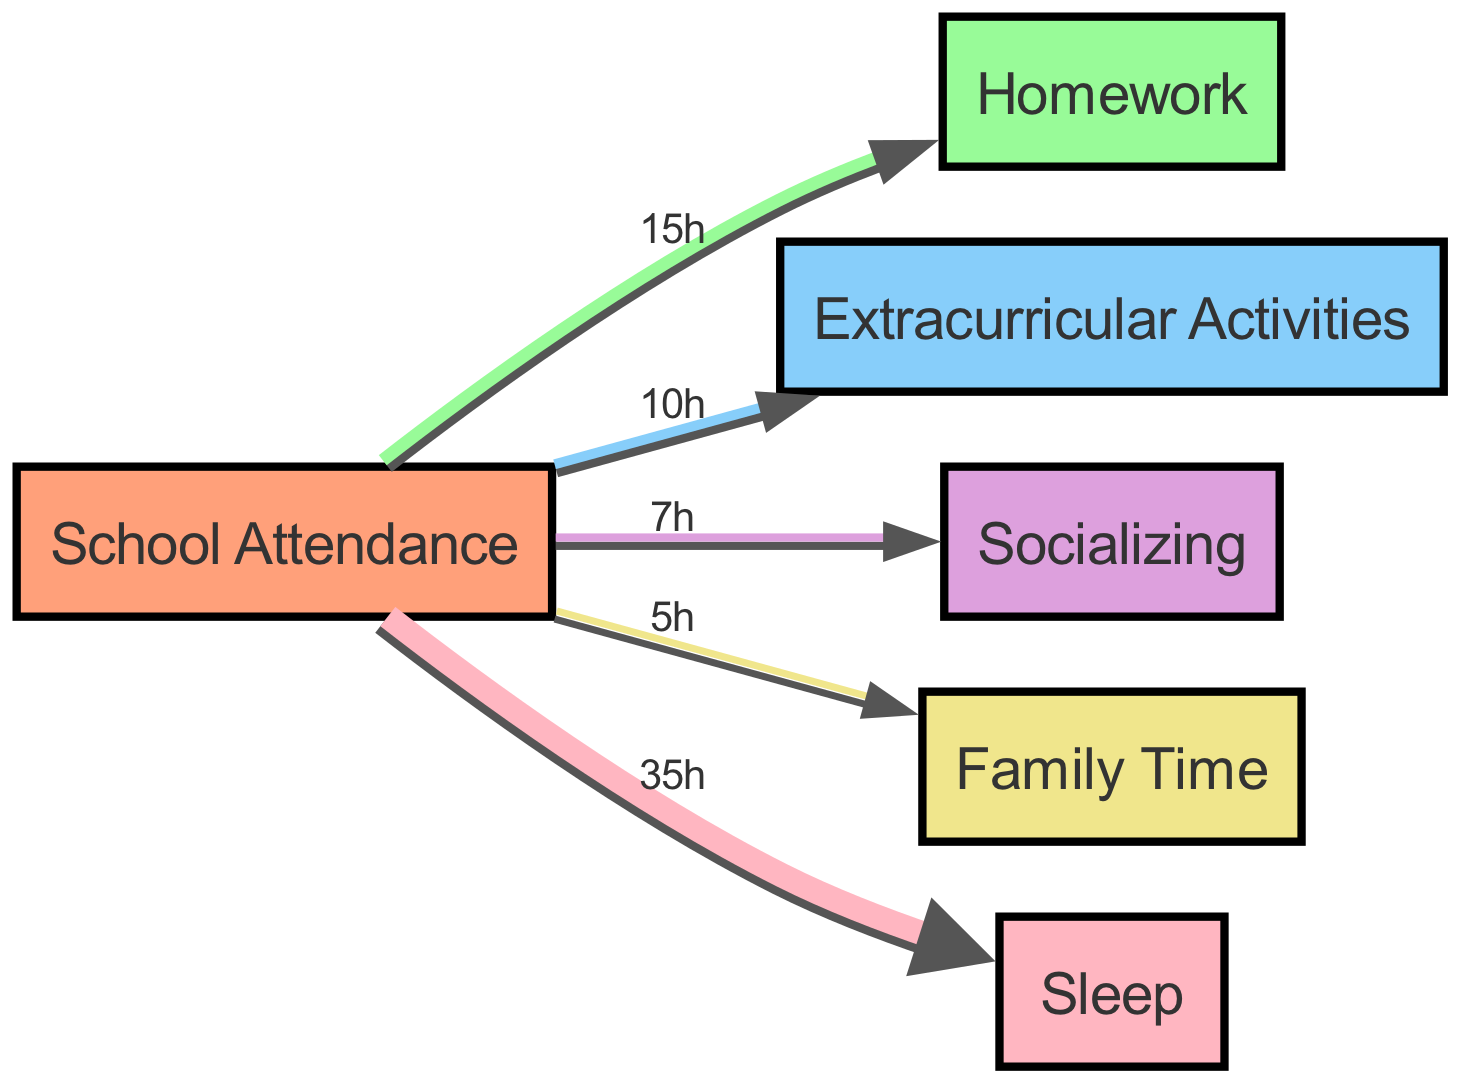What is the total time allocated for School Attendance? The total time allocated for School Attendance can be determined by summing all the flows that lead out of it, which represents the distribution of activities after attending school. Thus, 15 hours for Homework, 10 hours for Extracurricular Activities, 7 hours for Socializing, 5 hours for Family Time, and 35 hours for Sleep sum up to a total of 72 hours.
Answer: 72 hours Which activity has the highest time allocation? The activity with the highest time allocation is determined by comparing the values of the links connected to the nodes. Checking the flows from School Attendance: Homework (15 hours), Extracurricular Activities (10 hours), Socializing (7 hours), Family Time (5 hours), and Sleep (35 hours), we find that Sleep has the highest allocation with 35 hours.
Answer: Sleep How many nodes are present in the diagram? The number of nodes can be counted directly from the 'nodes' section of the data, where each entry represents a unique activity. There are 6 nodes: School Attendance, Homework, Extracurricular Activities, Socializing, Family Time, and Sleep.
Answer: 6 What is the time difference between Homework and Socializing? To find the time difference, we take the allocated time for Homework (15 hours) and Socializing (7 hours) and calculate 15 - 7, resulting in a difference. The workflow indicates that Homework is done for 15 hours, while Socializing takes 7 hours, so the difference is 8 hours.
Answer: 8 hours What portion of the time goes to Extracurricular Activities compared to Homework? This portion can be found by looking at the respective values connected to School Attendance. Extracurricular Activities is allocated 10 hours, while Homework is allocated 15 hours. To find the comparison, calculate the ratio of these times. Thus, Extracurricular Activities takes 10/15, which simplifies to 2/3 of the time spent on Homework.
Answer: 2/3 What percentage of total allocated time is spent on Family Time? To calculate the percentage of time spent on Family Time, we take the allocated hours for Family Time (5 hours) and divide it by the total time allocated from School Attendance (72 hours), then multiply by 100 to convert it to a percentage. This results in (5/72)*100, approximately 6.94%. So, around 7% of total time is dedicated to Family Time.
Answer: 7% What is the combined time for Socializing and Family Time? To find the combined time for Socializing and Family Time, we simply add the time allocated for both activities. Socializing is 7 hours, and Family Time is 5 hours. Adding these gives us 7 + 5 = 12 hours spent on both activities.
Answer: 12 hours 